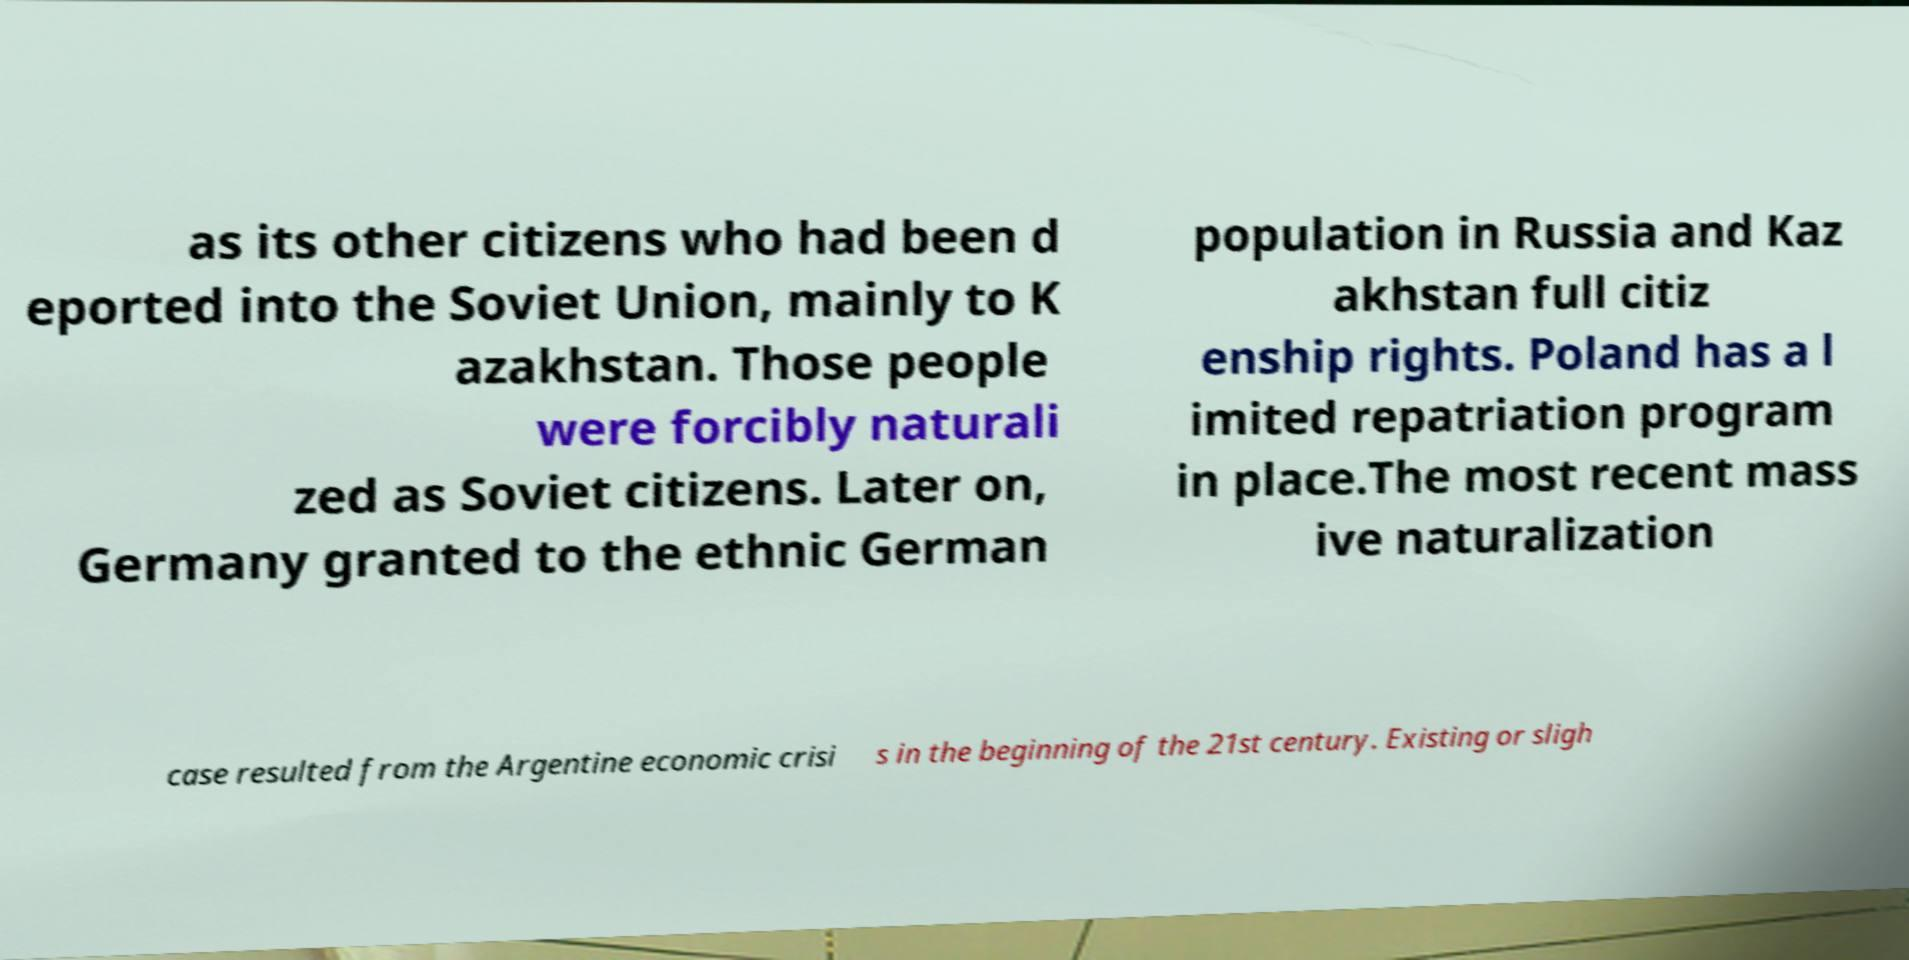Please read and relay the text visible in this image. What does it say? as its other citizens who had been d eported into the Soviet Union, mainly to K azakhstan. Those people were forcibly naturali zed as Soviet citizens. Later on, Germany granted to the ethnic German population in Russia and Kaz akhstan full citiz enship rights. Poland has a l imited repatriation program in place.The most recent mass ive naturalization case resulted from the Argentine economic crisi s in the beginning of the 21st century. Existing or sligh 